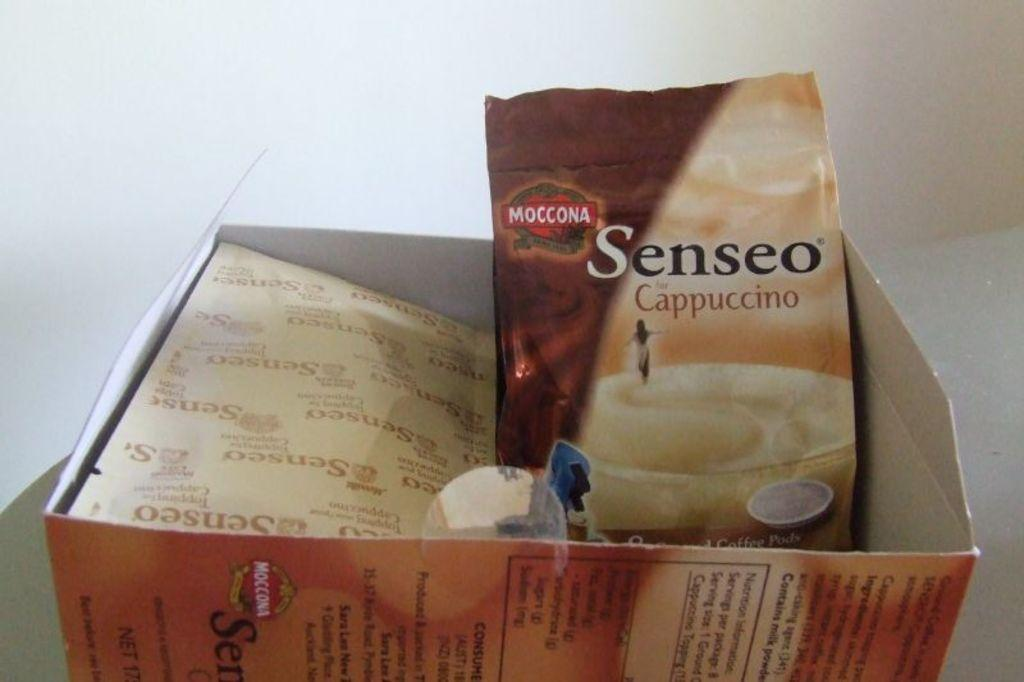<image>
Render a clear and concise summary of the photo. a Senseo Cappuccino coffee mix in an opened box. 